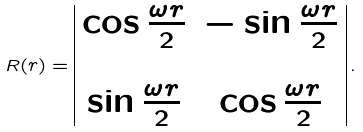<formula> <loc_0><loc_0><loc_500><loc_500>R ( r ) = \begin{array} { | c c | } \cos \frac { \omega r } { 2 } & - \sin \frac { \omega r } { 2 } \\ & \\ \sin \frac { \omega r } { 2 } & \cos \frac { \omega r } { 2 } \end{array} \, .</formula> 